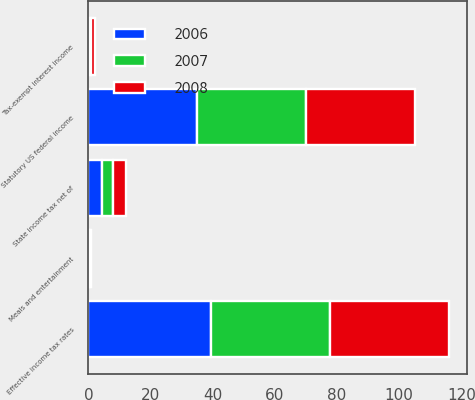Convert chart to OTSL. <chart><loc_0><loc_0><loc_500><loc_500><stacked_bar_chart><ecel><fcel>Statutory US federal income<fcel>State income tax net of<fcel>Meals and entertainment<fcel>Tax-exempt interest income<fcel>Effective income tax rates<nl><fcel>2007<fcel>35<fcel>3.7<fcel>0.3<fcel>0.5<fcel>38.5<nl><fcel>2008<fcel>35<fcel>4.2<fcel>0.3<fcel>1.5<fcel>38.1<nl><fcel>2006<fcel>35<fcel>4.3<fcel>0.2<fcel>0.2<fcel>39.3<nl></chart> 